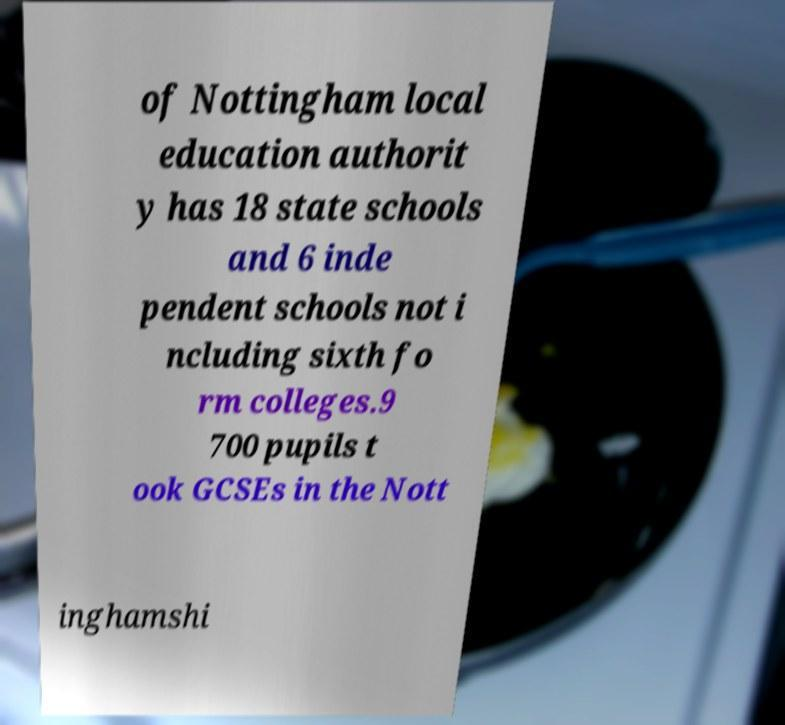There's text embedded in this image that I need extracted. Can you transcribe it verbatim? of Nottingham local education authorit y has 18 state schools and 6 inde pendent schools not i ncluding sixth fo rm colleges.9 700 pupils t ook GCSEs in the Nott inghamshi 